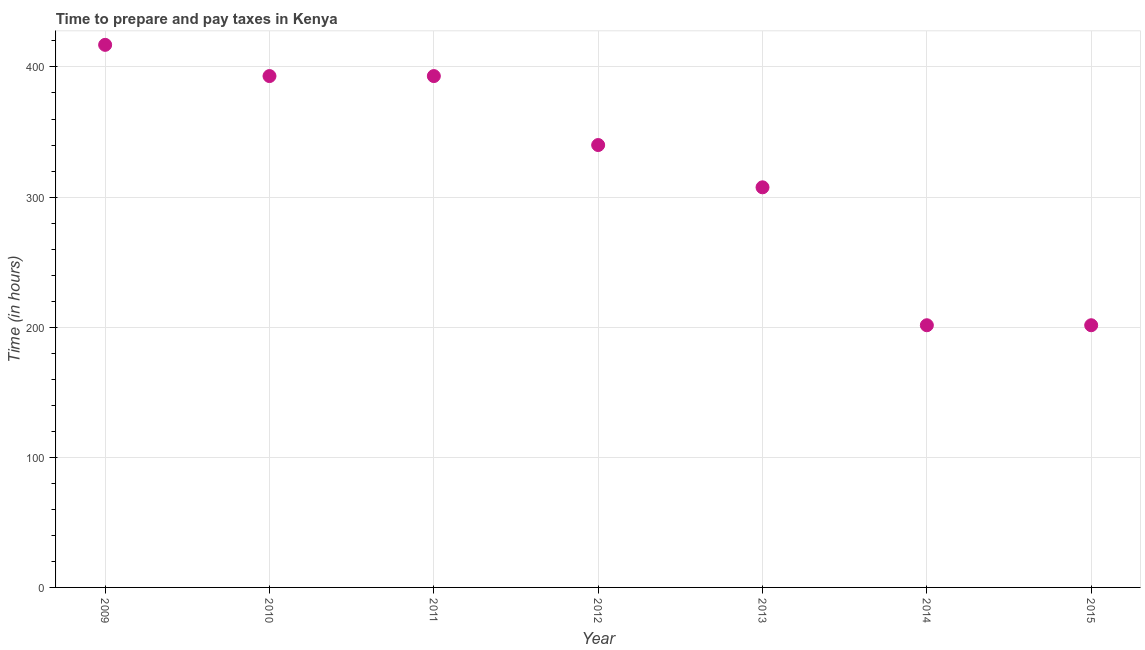What is the time to prepare and pay taxes in 2013?
Make the answer very short. 307.5. Across all years, what is the maximum time to prepare and pay taxes?
Your response must be concise. 417. Across all years, what is the minimum time to prepare and pay taxes?
Provide a short and direct response. 201.5. In which year was the time to prepare and pay taxes maximum?
Make the answer very short. 2009. What is the sum of the time to prepare and pay taxes?
Your response must be concise. 2253.5. What is the difference between the time to prepare and pay taxes in 2009 and 2011?
Offer a very short reply. 24. What is the average time to prepare and pay taxes per year?
Give a very brief answer. 321.93. What is the median time to prepare and pay taxes?
Ensure brevity in your answer.  340. In how many years, is the time to prepare and pay taxes greater than 280 hours?
Offer a very short reply. 5. Do a majority of the years between 2010 and 2014 (inclusive) have time to prepare and pay taxes greater than 200 hours?
Provide a short and direct response. Yes. What is the ratio of the time to prepare and pay taxes in 2012 to that in 2013?
Give a very brief answer. 1.11. Is the time to prepare and pay taxes in 2011 less than that in 2014?
Provide a succinct answer. No. Is the difference between the time to prepare and pay taxes in 2012 and 2014 greater than the difference between any two years?
Your answer should be compact. No. Is the sum of the time to prepare and pay taxes in 2012 and 2013 greater than the maximum time to prepare and pay taxes across all years?
Ensure brevity in your answer.  Yes. What is the difference between the highest and the lowest time to prepare and pay taxes?
Keep it short and to the point. 215.5. Does the time to prepare and pay taxes monotonically increase over the years?
Provide a short and direct response. No. How many dotlines are there?
Offer a very short reply. 1. How many years are there in the graph?
Your answer should be very brief. 7. What is the title of the graph?
Give a very brief answer. Time to prepare and pay taxes in Kenya. What is the label or title of the Y-axis?
Your answer should be very brief. Time (in hours). What is the Time (in hours) in 2009?
Ensure brevity in your answer.  417. What is the Time (in hours) in 2010?
Keep it short and to the point. 393. What is the Time (in hours) in 2011?
Offer a terse response. 393. What is the Time (in hours) in 2012?
Provide a short and direct response. 340. What is the Time (in hours) in 2013?
Your answer should be compact. 307.5. What is the Time (in hours) in 2014?
Provide a short and direct response. 201.5. What is the Time (in hours) in 2015?
Offer a terse response. 201.5. What is the difference between the Time (in hours) in 2009 and 2012?
Make the answer very short. 77. What is the difference between the Time (in hours) in 2009 and 2013?
Provide a short and direct response. 109.5. What is the difference between the Time (in hours) in 2009 and 2014?
Offer a very short reply. 215.5. What is the difference between the Time (in hours) in 2009 and 2015?
Ensure brevity in your answer.  215.5. What is the difference between the Time (in hours) in 2010 and 2012?
Keep it short and to the point. 53. What is the difference between the Time (in hours) in 2010 and 2013?
Give a very brief answer. 85.5. What is the difference between the Time (in hours) in 2010 and 2014?
Ensure brevity in your answer.  191.5. What is the difference between the Time (in hours) in 2010 and 2015?
Your answer should be compact. 191.5. What is the difference between the Time (in hours) in 2011 and 2012?
Your answer should be very brief. 53. What is the difference between the Time (in hours) in 2011 and 2013?
Make the answer very short. 85.5. What is the difference between the Time (in hours) in 2011 and 2014?
Provide a short and direct response. 191.5. What is the difference between the Time (in hours) in 2011 and 2015?
Provide a short and direct response. 191.5. What is the difference between the Time (in hours) in 2012 and 2013?
Provide a succinct answer. 32.5. What is the difference between the Time (in hours) in 2012 and 2014?
Give a very brief answer. 138.5. What is the difference between the Time (in hours) in 2012 and 2015?
Ensure brevity in your answer.  138.5. What is the difference between the Time (in hours) in 2013 and 2014?
Provide a short and direct response. 106. What is the difference between the Time (in hours) in 2013 and 2015?
Ensure brevity in your answer.  106. What is the difference between the Time (in hours) in 2014 and 2015?
Offer a terse response. 0. What is the ratio of the Time (in hours) in 2009 to that in 2010?
Offer a terse response. 1.06. What is the ratio of the Time (in hours) in 2009 to that in 2011?
Provide a short and direct response. 1.06. What is the ratio of the Time (in hours) in 2009 to that in 2012?
Offer a terse response. 1.23. What is the ratio of the Time (in hours) in 2009 to that in 2013?
Offer a terse response. 1.36. What is the ratio of the Time (in hours) in 2009 to that in 2014?
Make the answer very short. 2.07. What is the ratio of the Time (in hours) in 2009 to that in 2015?
Offer a very short reply. 2.07. What is the ratio of the Time (in hours) in 2010 to that in 2011?
Provide a succinct answer. 1. What is the ratio of the Time (in hours) in 2010 to that in 2012?
Offer a terse response. 1.16. What is the ratio of the Time (in hours) in 2010 to that in 2013?
Ensure brevity in your answer.  1.28. What is the ratio of the Time (in hours) in 2010 to that in 2014?
Ensure brevity in your answer.  1.95. What is the ratio of the Time (in hours) in 2010 to that in 2015?
Make the answer very short. 1.95. What is the ratio of the Time (in hours) in 2011 to that in 2012?
Offer a terse response. 1.16. What is the ratio of the Time (in hours) in 2011 to that in 2013?
Your answer should be very brief. 1.28. What is the ratio of the Time (in hours) in 2011 to that in 2014?
Keep it short and to the point. 1.95. What is the ratio of the Time (in hours) in 2011 to that in 2015?
Ensure brevity in your answer.  1.95. What is the ratio of the Time (in hours) in 2012 to that in 2013?
Offer a very short reply. 1.11. What is the ratio of the Time (in hours) in 2012 to that in 2014?
Ensure brevity in your answer.  1.69. What is the ratio of the Time (in hours) in 2012 to that in 2015?
Ensure brevity in your answer.  1.69. What is the ratio of the Time (in hours) in 2013 to that in 2014?
Offer a very short reply. 1.53. What is the ratio of the Time (in hours) in 2013 to that in 2015?
Keep it short and to the point. 1.53. 